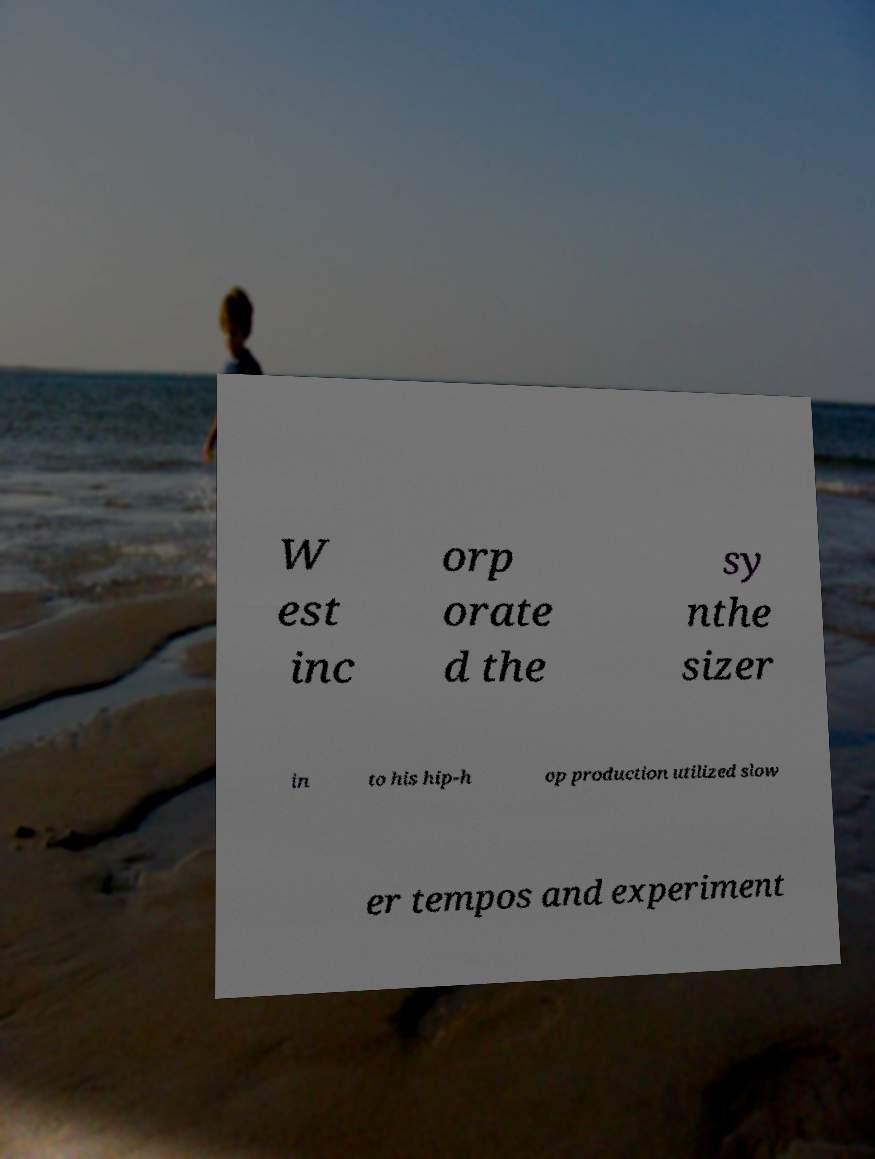There's text embedded in this image that I need extracted. Can you transcribe it verbatim? W est inc orp orate d the sy nthe sizer in to his hip-h op production utilized slow er tempos and experiment 